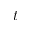Convert formula to latex. <formula><loc_0><loc_0><loc_500><loc_500>t</formula> 